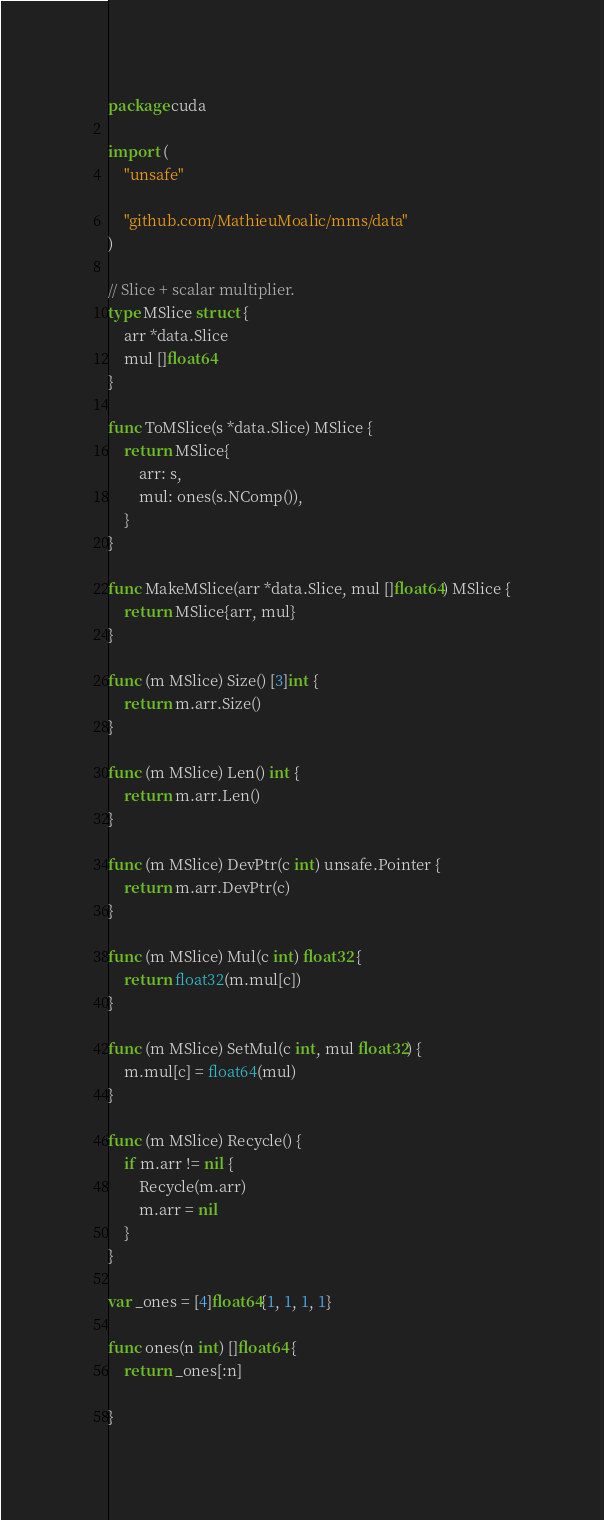Convert code to text. <code><loc_0><loc_0><loc_500><loc_500><_Go_>package cuda

import (
	"unsafe"

	"github.com/MathieuMoalic/mms/data"
)

// Slice + scalar multiplier.
type MSlice struct {
	arr *data.Slice
	mul []float64
}

func ToMSlice(s *data.Slice) MSlice {
	return MSlice{
		arr: s,
		mul: ones(s.NComp()),
	}
}

func MakeMSlice(arr *data.Slice, mul []float64) MSlice {
	return MSlice{arr, mul}
}

func (m MSlice) Size() [3]int {
	return m.arr.Size()
}

func (m MSlice) Len() int {
	return m.arr.Len()
}

func (m MSlice) DevPtr(c int) unsafe.Pointer {
	return m.arr.DevPtr(c)
}

func (m MSlice) Mul(c int) float32 {
	return float32(m.mul[c])
}

func (m MSlice) SetMul(c int, mul float32) {
	m.mul[c] = float64(mul)
}

func (m MSlice) Recycle() {
	if m.arr != nil {
		Recycle(m.arr)
		m.arr = nil
	}
}

var _ones = [4]float64{1, 1, 1, 1}

func ones(n int) []float64 {
	return _ones[:n]

}
</code> 